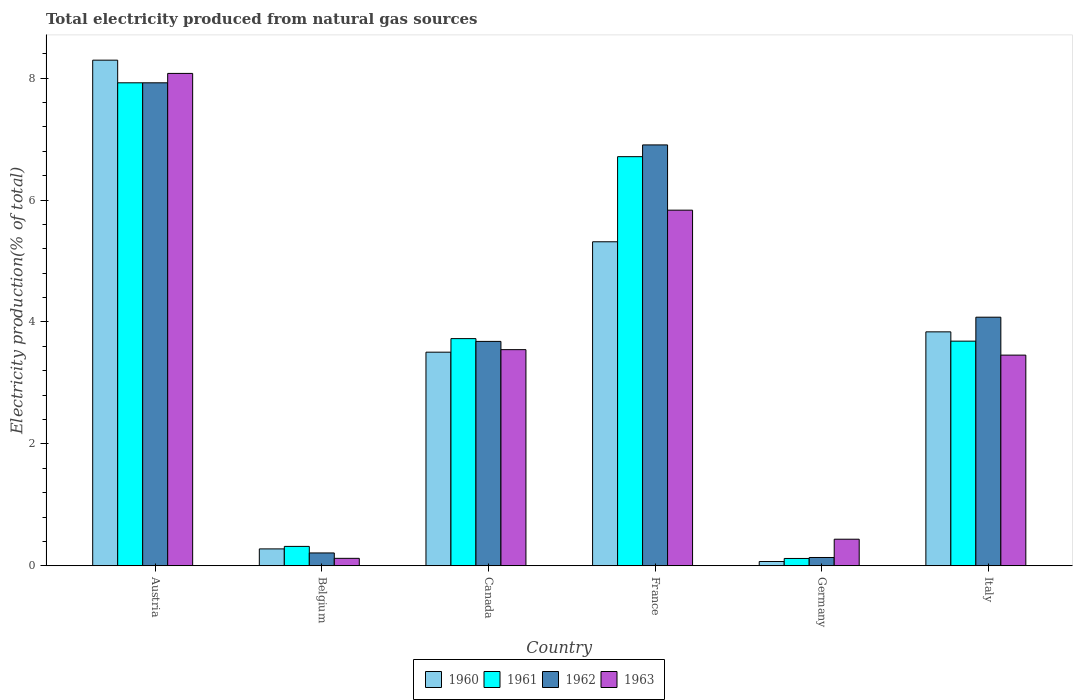How many different coloured bars are there?
Offer a very short reply. 4. Are the number of bars per tick equal to the number of legend labels?
Offer a very short reply. Yes. Are the number of bars on each tick of the X-axis equal?
Give a very brief answer. Yes. How many bars are there on the 6th tick from the right?
Keep it short and to the point. 4. What is the label of the 6th group of bars from the left?
Provide a short and direct response. Italy. In how many cases, is the number of bars for a given country not equal to the number of legend labels?
Offer a terse response. 0. What is the total electricity produced in 1962 in Italy?
Keep it short and to the point. 4.08. Across all countries, what is the maximum total electricity produced in 1961?
Your answer should be very brief. 7.92. Across all countries, what is the minimum total electricity produced in 1962?
Offer a terse response. 0.14. In which country was the total electricity produced in 1962 minimum?
Make the answer very short. Germany. What is the total total electricity produced in 1961 in the graph?
Offer a terse response. 22.49. What is the difference between the total electricity produced in 1961 in Germany and that in Italy?
Offer a very short reply. -3.57. What is the difference between the total electricity produced in 1962 in France and the total electricity produced in 1960 in Austria?
Make the answer very short. -1.39. What is the average total electricity produced in 1963 per country?
Make the answer very short. 3.58. What is the difference between the total electricity produced of/in 1961 and total electricity produced of/in 1962 in France?
Give a very brief answer. -0.19. In how many countries, is the total electricity produced in 1963 greater than 4.8 %?
Your answer should be compact. 2. What is the ratio of the total electricity produced in 1961 in Germany to that in Italy?
Offer a terse response. 0.03. Is the total electricity produced in 1960 in Belgium less than that in Italy?
Your answer should be very brief. Yes. Is the difference between the total electricity produced in 1961 in France and Italy greater than the difference between the total electricity produced in 1962 in France and Italy?
Make the answer very short. Yes. What is the difference between the highest and the second highest total electricity produced in 1960?
Your answer should be compact. 4.46. What is the difference between the highest and the lowest total electricity produced in 1960?
Your answer should be very brief. 8.23. In how many countries, is the total electricity produced in 1960 greater than the average total electricity produced in 1960 taken over all countries?
Make the answer very short. 3. What does the 3rd bar from the left in Austria represents?
Your answer should be compact. 1962. How many countries are there in the graph?
Your answer should be compact. 6. Does the graph contain any zero values?
Provide a succinct answer. No. What is the title of the graph?
Make the answer very short. Total electricity produced from natural gas sources. What is the Electricity production(% of total) of 1960 in Austria?
Make the answer very short. 8.3. What is the Electricity production(% of total) of 1961 in Austria?
Offer a terse response. 7.92. What is the Electricity production(% of total) in 1962 in Austria?
Make the answer very short. 7.92. What is the Electricity production(% of total) in 1963 in Austria?
Provide a succinct answer. 8.08. What is the Electricity production(% of total) of 1960 in Belgium?
Provide a succinct answer. 0.28. What is the Electricity production(% of total) in 1961 in Belgium?
Make the answer very short. 0.32. What is the Electricity production(% of total) in 1962 in Belgium?
Your response must be concise. 0.21. What is the Electricity production(% of total) of 1963 in Belgium?
Ensure brevity in your answer.  0.12. What is the Electricity production(% of total) in 1960 in Canada?
Your answer should be very brief. 3.5. What is the Electricity production(% of total) of 1961 in Canada?
Provide a succinct answer. 3.73. What is the Electricity production(% of total) of 1962 in Canada?
Offer a very short reply. 3.68. What is the Electricity production(% of total) of 1963 in Canada?
Ensure brevity in your answer.  3.55. What is the Electricity production(% of total) in 1960 in France?
Give a very brief answer. 5.32. What is the Electricity production(% of total) in 1961 in France?
Keep it short and to the point. 6.71. What is the Electricity production(% of total) of 1962 in France?
Your answer should be very brief. 6.91. What is the Electricity production(% of total) in 1963 in France?
Give a very brief answer. 5.83. What is the Electricity production(% of total) in 1960 in Germany?
Your answer should be very brief. 0.07. What is the Electricity production(% of total) of 1961 in Germany?
Provide a short and direct response. 0.12. What is the Electricity production(% of total) of 1962 in Germany?
Offer a terse response. 0.14. What is the Electricity production(% of total) of 1963 in Germany?
Your answer should be very brief. 0.44. What is the Electricity production(% of total) of 1960 in Italy?
Provide a short and direct response. 3.84. What is the Electricity production(% of total) in 1961 in Italy?
Make the answer very short. 3.69. What is the Electricity production(% of total) in 1962 in Italy?
Your response must be concise. 4.08. What is the Electricity production(% of total) of 1963 in Italy?
Provide a short and direct response. 3.46. Across all countries, what is the maximum Electricity production(% of total) of 1960?
Offer a very short reply. 8.3. Across all countries, what is the maximum Electricity production(% of total) of 1961?
Make the answer very short. 7.92. Across all countries, what is the maximum Electricity production(% of total) of 1962?
Keep it short and to the point. 7.92. Across all countries, what is the maximum Electricity production(% of total) of 1963?
Offer a very short reply. 8.08. Across all countries, what is the minimum Electricity production(% of total) in 1960?
Offer a terse response. 0.07. Across all countries, what is the minimum Electricity production(% of total) of 1961?
Give a very brief answer. 0.12. Across all countries, what is the minimum Electricity production(% of total) of 1962?
Your response must be concise. 0.14. Across all countries, what is the minimum Electricity production(% of total) of 1963?
Your response must be concise. 0.12. What is the total Electricity production(% of total) of 1960 in the graph?
Make the answer very short. 21.3. What is the total Electricity production(% of total) in 1961 in the graph?
Provide a succinct answer. 22.49. What is the total Electricity production(% of total) of 1962 in the graph?
Offer a very short reply. 22.94. What is the total Electricity production(% of total) in 1963 in the graph?
Give a very brief answer. 21.47. What is the difference between the Electricity production(% of total) in 1960 in Austria and that in Belgium?
Your response must be concise. 8.02. What is the difference between the Electricity production(% of total) of 1961 in Austria and that in Belgium?
Your answer should be compact. 7.61. What is the difference between the Electricity production(% of total) of 1962 in Austria and that in Belgium?
Provide a short and direct response. 7.71. What is the difference between the Electricity production(% of total) in 1963 in Austria and that in Belgium?
Give a very brief answer. 7.96. What is the difference between the Electricity production(% of total) in 1960 in Austria and that in Canada?
Your answer should be very brief. 4.79. What is the difference between the Electricity production(% of total) in 1961 in Austria and that in Canada?
Offer a very short reply. 4.2. What is the difference between the Electricity production(% of total) of 1962 in Austria and that in Canada?
Your answer should be compact. 4.24. What is the difference between the Electricity production(% of total) in 1963 in Austria and that in Canada?
Give a very brief answer. 4.53. What is the difference between the Electricity production(% of total) in 1960 in Austria and that in France?
Ensure brevity in your answer.  2.98. What is the difference between the Electricity production(% of total) in 1961 in Austria and that in France?
Offer a very short reply. 1.21. What is the difference between the Electricity production(% of total) in 1962 in Austria and that in France?
Make the answer very short. 1.02. What is the difference between the Electricity production(% of total) of 1963 in Austria and that in France?
Make the answer very short. 2.24. What is the difference between the Electricity production(% of total) of 1960 in Austria and that in Germany?
Offer a very short reply. 8.23. What is the difference between the Electricity production(% of total) in 1961 in Austria and that in Germany?
Give a very brief answer. 7.8. What is the difference between the Electricity production(% of total) of 1962 in Austria and that in Germany?
Ensure brevity in your answer.  7.79. What is the difference between the Electricity production(% of total) in 1963 in Austria and that in Germany?
Offer a very short reply. 7.64. What is the difference between the Electricity production(% of total) of 1960 in Austria and that in Italy?
Offer a very short reply. 4.46. What is the difference between the Electricity production(% of total) of 1961 in Austria and that in Italy?
Give a very brief answer. 4.24. What is the difference between the Electricity production(% of total) in 1962 in Austria and that in Italy?
Provide a succinct answer. 3.85. What is the difference between the Electricity production(% of total) in 1963 in Austria and that in Italy?
Provide a succinct answer. 4.62. What is the difference between the Electricity production(% of total) of 1960 in Belgium and that in Canada?
Ensure brevity in your answer.  -3.23. What is the difference between the Electricity production(% of total) in 1961 in Belgium and that in Canada?
Your response must be concise. -3.41. What is the difference between the Electricity production(% of total) in 1962 in Belgium and that in Canada?
Your answer should be very brief. -3.47. What is the difference between the Electricity production(% of total) in 1963 in Belgium and that in Canada?
Offer a very short reply. -3.42. What is the difference between the Electricity production(% of total) of 1960 in Belgium and that in France?
Ensure brevity in your answer.  -5.04. What is the difference between the Electricity production(% of total) in 1961 in Belgium and that in France?
Your answer should be very brief. -6.39. What is the difference between the Electricity production(% of total) of 1962 in Belgium and that in France?
Offer a terse response. -6.69. What is the difference between the Electricity production(% of total) of 1963 in Belgium and that in France?
Offer a terse response. -5.71. What is the difference between the Electricity production(% of total) of 1960 in Belgium and that in Germany?
Provide a succinct answer. 0.21. What is the difference between the Electricity production(% of total) in 1961 in Belgium and that in Germany?
Your response must be concise. 0.2. What is the difference between the Electricity production(% of total) of 1962 in Belgium and that in Germany?
Your answer should be compact. 0.07. What is the difference between the Electricity production(% of total) of 1963 in Belgium and that in Germany?
Offer a terse response. -0.31. What is the difference between the Electricity production(% of total) in 1960 in Belgium and that in Italy?
Provide a short and direct response. -3.56. What is the difference between the Electricity production(% of total) in 1961 in Belgium and that in Italy?
Ensure brevity in your answer.  -3.37. What is the difference between the Electricity production(% of total) in 1962 in Belgium and that in Italy?
Offer a terse response. -3.87. What is the difference between the Electricity production(% of total) of 1963 in Belgium and that in Italy?
Offer a very short reply. -3.33. What is the difference between the Electricity production(% of total) in 1960 in Canada and that in France?
Your response must be concise. -1.81. What is the difference between the Electricity production(% of total) in 1961 in Canada and that in France?
Offer a very short reply. -2.99. What is the difference between the Electricity production(% of total) in 1962 in Canada and that in France?
Your answer should be very brief. -3.22. What is the difference between the Electricity production(% of total) of 1963 in Canada and that in France?
Offer a very short reply. -2.29. What is the difference between the Electricity production(% of total) in 1960 in Canada and that in Germany?
Ensure brevity in your answer.  3.43. What is the difference between the Electricity production(% of total) of 1961 in Canada and that in Germany?
Your response must be concise. 3.61. What is the difference between the Electricity production(% of total) in 1962 in Canada and that in Germany?
Make the answer very short. 3.55. What is the difference between the Electricity production(% of total) of 1963 in Canada and that in Germany?
Give a very brief answer. 3.11. What is the difference between the Electricity production(% of total) of 1960 in Canada and that in Italy?
Ensure brevity in your answer.  -0.33. What is the difference between the Electricity production(% of total) in 1961 in Canada and that in Italy?
Provide a succinct answer. 0.04. What is the difference between the Electricity production(% of total) of 1962 in Canada and that in Italy?
Provide a short and direct response. -0.4. What is the difference between the Electricity production(% of total) in 1963 in Canada and that in Italy?
Your response must be concise. 0.09. What is the difference between the Electricity production(% of total) of 1960 in France and that in Germany?
Provide a succinct answer. 5.25. What is the difference between the Electricity production(% of total) in 1961 in France and that in Germany?
Your response must be concise. 6.59. What is the difference between the Electricity production(% of total) in 1962 in France and that in Germany?
Give a very brief answer. 6.77. What is the difference between the Electricity production(% of total) of 1963 in France and that in Germany?
Provide a succinct answer. 5.4. What is the difference between the Electricity production(% of total) in 1960 in France and that in Italy?
Give a very brief answer. 1.48. What is the difference between the Electricity production(% of total) of 1961 in France and that in Italy?
Keep it short and to the point. 3.03. What is the difference between the Electricity production(% of total) in 1962 in France and that in Italy?
Offer a very short reply. 2.83. What is the difference between the Electricity production(% of total) in 1963 in France and that in Italy?
Your answer should be very brief. 2.38. What is the difference between the Electricity production(% of total) of 1960 in Germany and that in Italy?
Your answer should be very brief. -3.77. What is the difference between the Electricity production(% of total) of 1961 in Germany and that in Italy?
Provide a short and direct response. -3.57. What is the difference between the Electricity production(% of total) in 1962 in Germany and that in Italy?
Your answer should be compact. -3.94. What is the difference between the Electricity production(% of total) of 1963 in Germany and that in Italy?
Your answer should be very brief. -3.02. What is the difference between the Electricity production(% of total) of 1960 in Austria and the Electricity production(% of total) of 1961 in Belgium?
Offer a terse response. 7.98. What is the difference between the Electricity production(% of total) of 1960 in Austria and the Electricity production(% of total) of 1962 in Belgium?
Your answer should be compact. 8.08. What is the difference between the Electricity production(% of total) of 1960 in Austria and the Electricity production(% of total) of 1963 in Belgium?
Make the answer very short. 8.17. What is the difference between the Electricity production(% of total) of 1961 in Austria and the Electricity production(% of total) of 1962 in Belgium?
Your answer should be very brief. 7.71. What is the difference between the Electricity production(% of total) of 1961 in Austria and the Electricity production(% of total) of 1963 in Belgium?
Offer a very short reply. 7.8. What is the difference between the Electricity production(% of total) in 1962 in Austria and the Electricity production(% of total) in 1963 in Belgium?
Offer a very short reply. 7.8. What is the difference between the Electricity production(% of total) in 1960 in Austria and the Electricity production(% of total) in 1961 in Canada?
Provide a succinct answer. 4.57. What is the difference between the Electricity production(% of total) in 1960 in Austria and the Electricity production(% of total) in 1962 in Canada?
Provide a succinct answer. 4.61. What is the difference between the Electricity production(% of total) of 1960 in Austria and the Electricity production(% of total) of 1963 in Canada?
Give a very brief answer. 4.75. What is the difference between the Electricity production(% of total) of 1961 in Austria and the Electricity production(% of total) of 1962 in Canada?
Ensure brevity in your answer.  4.24. What is the difference between the Electricity production(% of total) in 1961 in Austria and the Electricity production(% of total) in 1963 in Canada?
Offer a terse response. 4.38. What is the difference between the Electricity production(% of total) in 1962 in Austria and the Electricity production(% of total) in 1963 in Canada?
Your answer should be compact. 4.38. What is the difference between the Electricity production(% of total) of 1960 in Austria and the Electricity production(% of total) of 1961 in France?
Give a very brief answer. 1.58. What is the difference between the Electricity production(% of total) of 1960 in Austria and the Electricity production(% of total) of 1962 in France?
Provide a succinct answer. 1.39. What is the difference between the Electricity production(% of total) of 1960 in Austria and the Electricity production(% of total) of 1963 in France?
Make the answer very short. 2.46. What is the difference between the Electricity production(% of total) in 1961 in Austria and the Electricity production(% of total) in 1962 in France?
Provide a succinct answer. 1.02. What is the difference between the Electricity production(% of total) of 1961 in Austria and the Electricity production(% of total) of 1963 in France?
Provide a short and direct response. 2.09. What is the difference between the Electricity production(% of total) of 1962 in Austria and the Electricity production(% of total) of 1963 in France?
Make the answer very short. 2.09. What is the difference between the Electricity production(% of total) in 1960 in Austria and the Electricity production(% of total) in 1961 in Germany?
Provide a short and direct response. 8.18. What is the difference between the Electricity production(% of total) of 1960 in Austria and the Electricity production(% of total) of 1962 in Germany?
Offer a terse response. 8.16. What is the difference between the Electricity production(% of total) in 1960 in Austria and the Electricity production(% of total) in 1963 in Germany?
Provide a succinct answer. 7.86. What is the difference between the Electricity production(% of total) of 1961 in Austria and the Electricity production(% of total) of 1962 in Germany?
Offer a very short reply. 7.79. What is the difference between the Electricity production(% of total) of 1961 in Austria and the Electricity production(% of total) of 1963 in Germany?
Ensure brevity in your answer.  7.49. What is the difference between the Electricity production(% of total) in 1962 in Austria and the Electricity production(% of total) in 1963 in Germany?
Keep it short and to the point. 7.49. What is the difference between the Electricity production(% of total) in 1960 in Austria and the Electricity production(% of total) in 1961 in Italy?
Offer a very short reply. 4.61. What is the difference between the Electricity production(% of total) in 1960 in Austria and the Electricity production(% of total) in 1962 in Italy?
Keep it short and to the point. 4.22. What is the difference between the Electricity production(% of total) in 1960 in Austria and the Electricity production(% of total) in 1963 in Italy?
Ensure brevity in your answer.  4.84. What is the difference between the Electricity production(% of total) of 1961 in Austria and the Electricity production(% of total) of 1962 in Italy?
Provide a succinct answer. 3.85. What is the difference between the Electricity production(% of total) in 1961 in Austria and the Electricity production(% of total) in 1963 in Italy?
Your answer should be very brief. 4.47. What is the difference between the Electricity production(% of total) in 1962 in Austria and the Electricity production(% of total) in 1963 in Italy?
Give a very brief answer. 4.47. What is the difference between the Electricity production(% of total) in 1960 in Belgium and the Electricity production(% of total) in 1961 in Canada?
Offer a very short reply. -3.45. What is the difference between the Electricity production(% of total) of 1960 in Belgium and the Electricity production(% of total) of 1962 in Canada?
Keep it short and to the point. -3.4. What is the difference between the Electricity production(% of total) in 1960 in Belgium and the Electricity production(% of total) in 1963 in Canada?
Provide a short and direct response. -3.27. What is the difference between the Electricity production(% of total) of 1961 in Belgium and the Electricity production(% of total) of 1962 in Canada?
Your answer should be very brief. -3.36. What is the difference between the Electricity production(% of total) in 1961 in Belgium and the Electricity production(% of total) in 1963 in Canada?
Make the answer very short. -3.23. What is the difference between the Electricity production(% of total) in 1962 in Belgium and the Electricity production(% of total) in 1963 in Canada?
Offer a terse response. -3.34. What is the difference between the Electricity production(% of total) of 1960 in Belgium and the Electricity production(% of total) of 1961 in France?
Provide a short and direct response. -6.43. What is the difference between the Electricity production(% of total) in 1960 in Belgium and the Electricity production(% of total) in 1962 in France?
Provide a short and direct response. -6.63. What is the difference between the Electricity production(% of total) in 1960 in Belgium and the Electricity production(% of total) in 1963 in France?
Ensure brevity in your answer.  -5.56. What is the difference between the Electricity production(% of total) in 1961 in Belgium and the Electricity production(% of total) in 1962 in France?
Your answer should be compact. -6.59. What is the difference between the Electricity production(% of total) in 1961 in Belgium and the Electricity production(% of total) in 1963 in France?
Your answer should be very brief. -5.52. What is the difference between the Electricity production(% of total) of 1962 in Belgium and the Electricity production(% of total) of 1963 in France?
Your answer should be compact. -5.62. What is the difference between the Electricity production(% of total) in 1960 in Belgium and the Electricity production(% of total) in 1961 in Germany?
Your answer should be compact. 0.16. What is the difference between the Electricity production(% of total) in 1960 in Belgium and the Electricity production(% of total) in 1962 in Germany?
Keep it short and to the point. 0.14. What is the difference between the Electricity production(% of total) of 1960 in Belgium and the Electricity production(% of total) of 1963 in Germany?
Provide a short and direct response. -0.16. What is the difference between the Electricity production(% of total) in 1961 in Belgium and the Electricity production(% of total) in 1962 in Germany?
Make the answer very short. 0.18. What is the difference between the Electricity production(% of total) in 1961 in Belgium and the Electricity production(% of total) in 1963 in Germany?
Your answer should be compact. -0.12. What is the difference between the Electricity production(% of total) in 1962 in Belgium and the Electricity production(% of total) in 1963 in Germany?
Keep it short and to the point. -0.23. What is the difference between the Electricity production(% of total) of 1960 in Belgium and the Electricity production(% of total) of 1961 in Italy?
Offer a terse response. -3.41. What is the difference between the Electricity production(% of total) of 1960 in Belgium and the Electricity production(% of total) of 1962 in Italy?
Make the answer very short. -3.8. What is the difference between the Electricity production(% of total) in 1960 in Belgium and the Electricity production(% of total) in 1963 in Italy?
Ensure brevity in your answer.  -3.18. What is the difference between the Electricity production(% of total) of 1961 in Belgium and the Electricity production(% of total) of 1962 in Italy?
Keep it short and to the point. -3.76. What is the difference between the Electricity production(% of total) of 1961 in Belgium and the Electricity production(% of total) of 1963 in Italy?
Ensure brevity in your answer.  -3.14. What is the difference between the Electricity production(% of total) in 1962 in Belgium and the Electricity production(% of total) in 1963 in Italy?
Give a very brief answer. -3.25. What is the difference between the Electricity production(% of total) of 1960 in Canada and the Electricity production(% of total) of 1961 in France?
Offer a terse response. -3.21. What is the difference between the Electricity production(% of total) in 1960 in Canada and the Electricity production(% of total) in 1962 in France?
Make the answer very short. -3.4. What is the difference between the Electricity production(% of total) in 1960 in Canada and the Electricity production(% of total) in 1963 in France?
Your answer should be compact. -2.33. What is the difference between the Electricity production(% of total) in 1961 in Canada and the Electricity production(% of total) in 1962 in France?
Give a very brief answer. -3.18. What is the difference between the Electricity production(% of total) in 1961 in Canada and the Electricity production(% of total) in 1963 in France?
Offer a very short reply. -2.11. What is the difference between the Electricity production(% of total) of 1962 in Canada and the Electricity production(% of total) of 1963 in France?
Make the answer very short. -2.15. What is the difference between the Electricity production(% of total) of 1960 in Canada and the Electricity production(% of total) of 1961 in Germany?
Make the answer very short. 3.38. What is the difference between the Electricity production(% of total) of 1960 in Canada and the Electricity production(% of total) of 1962 in Germany?
Ensure brevity in your answer.  3.37. What is the difference between the Electricity production(% of total) of 1960 in Canada and the Electricity production(% of total) of 1963 in Germany?
Ensure brevity in your answer.  3.07. What is the difference between the Electricity production(% of total) in 1961 in Canada and the Electricity production(% of total) in 1962 in Germany?
Provide a succinct answer. 3.59. What is the difference between the Electricity production(% of total) of 1961 in Canada and the Electricity production(% of total) of 1963 in Germany?
Offer a very short reply. 3.29. What is the difference between the Electricity production(% of total) of 1962 in Canada and the Electricity production(% of total) of 1963 in Germany?
Your answer should be compact. 3.25. What is the difference between the Electricity production(% of total) of 1960 in Canada and the Electricity production(% of total) of 1961 in Italy?
Ensure brevity in your answer.  -0.18. What is the difference between the Electricity production(% of total) in 1960 in Canada and the Electricity production(% of total) in 1962 in Italy?
Give a very brief answer. -0.57. What is the difference between the Electricity production(% of total) in 1960 in Canada and the Electricity production(% of total) in 1963 in Italy?
Give a very brief answer. 0.05. What is the difference between the Electricity production(% of total) in 1961 in Canada and the Electricity production(% of total) in 1962 in Italy?
Keep it short and to the point. -0.35. What is the difference between the Electricity production(% of total) of 1961 in Canada and the Electricity production(% of total) of 1963 in Italy?
Your response must be concise. 0.27. What is the difference between the Electricity production(% of total) in 1962 in Canada and the Electricity production(% of total) in 1963 in Italy?
Offer a very short reply. 0.23. What is the difference between the Electricity production(% of total) in 1960 in France and the Electricity production(% of total) in 1961 in Germany?
Keep it short and to the point. 5.2. What is the difference between the Electricity production(% of total) in 1960 in France and the Electricity production(% of total) in 1962 in Germany?
Ensure brevity in your answer.  5.18. What is the difference between the Electricity production(% of total) in 1960 in France and the Electricity production(% of total) in 1963 in Germany?
Offer a very short reply. 4.88. What is the difference between the Electricity production(% of total) of 1961 in France and the Electricity production(% of total) of 1962 in Germany?
Your response must be concise. 6.58. What is the difference between the Electricity production(% of total) in 1961 in France and the Electricity production(% of total) in 1963 in Germany?
Offer a terse response. 6.28. What is the difference between the Electricity production(% of total) of 1962 in France and the Electricity production(% of total) of 1963 in Germany?
Ensure brevity in your answer.  6.47. What is the difference between the Electricity production(% of total) of 1960 in France and the Electricity production(% of total) of 1961 in Italy?
Your response must be concise. 1.63. What is the difference between the Electricity production(% of total) of 1960 in France and the Electricity production(% of total) of 1962 in Italy?
Your answer should be compact. 1.24. What is the difference between the Electricity production(% of total) in 1960 in France and the Electricity production(% of total) in 1963 in Italy?
Make the answer very short. 1.86. What is the difference between the Electricity production(% of total) in 1961 in France and the Electricity production(% of total) in 1962 in Italy?
Ensure brevity in your answer.  2.63. What is the difference between the Electricity production(% of total) of 1961 in France and the Electricity production(% of total) of 1963 in Italy?
Your answer should be compact. 3.26. What is the difference between the Electricity production(% of total) of 1962 in France and the Electricity production(% of total) of 1963 in Italy?
Your response must be concise. 3.45. What is the difference between the Electricity production(% of total) of 1960 in Germany and the Electricity production(% of total) of 1961 in Italy?
Your answer should be compact. -3.62. What is the difference between the Electricity production(% of total) in 1960 in Germany and the Electricity production(% of total) in 1962 in Italy?
Offer a terse response. -4.01. What is the difference between the Electricity production(% of total) in 1960 in Germany and the Electricity production(% of total) in 1963 in Italy?
Make the answer very short. -3.39. What is the difference between the Electricity production(% of total) in 1961 in Germany and the Electricity production(% of total) in 1962 in Italy?
Your response must be concise. -3.96. What is the difference between the Electricity production(% of total) in 1961 in Germany and the Electricity production(% of total) in 1963 in Italy?
Give a very brief answer. -3.34. What is the difference between the Electricity production(% of total) in 1962 in Germany and the Electricity production(% of total) in 1963 in Italy?
Keep it short and to the point. -3.32. What is the average Electricity production(% of total) of 1960 per country?
Ensure brevity in your answer.  3.55. What is the average Electricity production(% of total) in 1961 per country?
Ensure brevity in your answer.  3.75. What is the average Electricity production(% of total) in 1962 per country?
Give a very brief answer. 3.82. What is the average Electricity production(% of total) of 1963 per country?
Give a very brief answer. 3.58. What is the difference between the Electricity production(% of total) in 1960 and Electricity production(% of total) in 1961 in Austria?
Make the answer very short. 0.37. What is the difference between the Electricity production(% of total) in 1960 and Electricity production(% of total) in 1962 in Austria?
Offer a very short reply. 0.37. What is the difference between the Electricity production(% of total) in 1960 and Electricity production(% of total) in 1963 in Austria?
Your response must be concise. 0.22. What is the difference between the Electricity production(% of total) of 1961 and Electricity production(% of total) of 1963 in Austria?
Your answer should be very brief. -0.15. What is the difference between the Electricity production(% of total) in 1962 and Electricity production(% of total) in 1963 in Austria?
Your answer should be compact. -0.15. What is the difference between the Electricity production(% of total) of 1960 and Electricity production(% of total) of 1961 in Belgium?
Ensure brevity in your answer.  -0.04. What is the difference between the Electricity production(% of total) of 1960 and Electricity production(% of total) of 1962 in Belgium?
Offer a terse response. 0.07. What is the difference between the Electricity production(% of total) of 1960 and Electricity production(% of total) of 1963 in Belgium?
Make the answer very short. 0.15. What is the difference between the Electricity production(% of total) of 1961 and Electricity production(% of total) of 1962 in Belgium?
Your answer should be very brief. 0.11. What is the difference between the Electricity production(% of total) in 1961 and Electricity production(% of total) in 1963 in Belgium?
Your answer should be very brief. 0.2. What is the difference between the Electricity production(% of total) in 1962 and Electricity production(% of total) in 1963 in Belgium?
Keep it short and to the point. 0.09. What is the difference between the Electricity production(% of total) of 1960 and Electricity production(% of total) of 1961 in Canada?
Give a very brief answer. -0.22. What is the difference between the Electricity production(% of total) in 1960 and Electricity production(% of total) in 1962 in Canada?
Provide a succinct answer. -0.18. What is the difference between the Electricity production(% of total) of 1960 and Electricity production(% of total) of 1963 in Canada?
Make the answer very short. -0.04. What is the difference between the Electricity production(% of total) of 1961 and Electricity production(% of total) of 1962 in Canada?
Make the answer very short. 0.05. What is the difference between the Electricity production(% of total) in 1961 and Electricity production(% of total) in 1963 in Canada?
Ensure brevity in your answer.  0.18. What is the difference between the Electricity production(% of total) in 1962 and Electricity production(% of total) in 1963 in Canada?
Make the answer very short. 0.14. What is the difference between the Electricity production(% of total) in 1960 and Electricity production(% of total) in 1961 in France?
Offer a terse response. -1.4. What is the difference between the Electricity production(% of total) in 1960 and Electricity production(% of total) in 1962 in France?
Ensure brevity in your answer.  -1.59. What is the difference between the Electricity production(% of total) of 1960 and Electricity production(% of total) of 1963 in France?
Give a very brief answer. -0.52. What is the difference between the Electricity production(% of total) of 1961 and Electricity production(% of total) of 1962 in France?
Ensure brevity in your answer.  -0.19. What is the difference between the Electricity production(% of total) of 1961 and Electricity production(% of total) of 1963 in France?
Offer a very short reply. 0.88. What is the difference between the Electricity production(% of total) in 1962 and Electricity production(% of total) in 1963 in France?
Your answer should be very brief. 1.07. What is the difference between the Electricity production(% of total) of 1960 and Electricity production(% of total) of 1961 in Germany?
Provide a succinct answer. -0.05. What is the difference between the Electricity production(% of total) of 1960 and Electricity production(% of total) of 1962 in Germany?
Keep it short and to the point. -0.07. What is the difference between the Electricity production(% of total) of 1960 and Electricity production(% of total) of 1963 in Germany?
Your response must be concise. -0.37. What is the difference between the Electricity production(% of total) in 1961 and Electricity production(% of total) in 1962 in Germany?
Offer a very short reply. -0.02. What is the difference between the Electricity production(% of total) in 1961 and Electricity production(% of total) in 1963 in Germany?
Make the answer very short. -0.32. What is the difference between the Electricity production(% of total) of 1962 and Electricity production(% of total) of 1963 in Germany?
Ensure brevity in your answer.  -0.3. What is the difference between the Electricity production(% of total) of 1960 and Electricity production(% of total) of 1961 in Italy?
Make the answer very short. 0.15. What is the difference between the Electricity production(% of total) in 1960 and Electricity production(% of total) in 1962 in Italy?
Make the answer very short. -0.24. What is the difference between the Electricity production(% of total) in 1960 and Electricity production(% of total) in 1963 in Italy?
Your answer should be very brief. 0.38. What is the difference between the Electricity production(% of total) in 1961 and Electricity production(% of total) in 1962 in Italy?
Give a very brief answer. -0.39. What is the difference between the Electricity production(% of total) of 1961 and Electricity production(% of total) of 1963 in Italy?
Provide a succinct answer. 0.23. What is the difference between the Electricity production(% of total) in 1962 and Electricity production(% of total) in 1963 in Italy?
Offer a terse response. 0.62. What is the ratio of the Electricity production(% of total) of 1960 in Austria to that in Belgium?
Your response must be concise. 29.93. What is the ratio of the Electricity production(% of total) in 1961 in Austria to that in Belgium?
Ensure brevity in your answer.  24.9. What is the ratio of the Electricity production(% of total) in 1962 in Austria to that in Belgium?
Give a very brief answer. 37.57. What is the ratio of the Electricity production(% of total) in 1963 in Austria to that in Belgium?
Make the answer very short. 66.07. What is the ratio of the Electricity production(% of total) in 1960 in Austria to that in Canada?
Offer a very short reply. 2.37. What is the ratio of the Electricity production(% of total) in 1961 in Austria to that in Canada?
Your answer should be compact. 2.13. What is the ratio of the Electricity production(% of total) in 1962 in Austria to that in Canada?
Your answer should be compact. 2.15. What is the ratio of the Electricity production(% of total) in 1963 in Austria to that in Canada?
Ensure brevity in your answer.  2.28. What is the ratio of the Electricity production(% of total) in 1960 in Austria to that in France?
Ensure brevity in your answer.  1.56. What is the ratio of the Electricity production(% of total) in 1961 in Austria to that in France?
Your answer should be very brief. 1.18. What is the ratio of the Electricity production(% of total) of 1962 in Austria to that in France?
Your response must be concise. 1.15. What is the ratio of the Electricity production(% of total) of 1963 in Austria to that in France?
Offer a terse response. 1.38. What is the ratio of the Electricity production(% of total) of 1960 in Austria to that in Germany?
Offer a very short reply. 118.01. What is the ratio of the Electricity production(% of total) of 1961 in Austria to that in Germany?
Provide a succinct answer. 65.86. What is the ratio of the Electricity production(% of total) in 1962 in Austria to that in Germany?
Offer a very short reply. 58.17. What is the ratio of the Electricity production(% of total) of 1963 in Austria to that in Germany?
Your answer should be very brief. 18.52. What is the ratio of the Electricity production(% of total) in 1960 in Austria to that in Italy?
Offer a terse response. 2.16. What is the ratio of the Electricity production(% of total) of 1961 in Austria to that in Italy?
Ensure brevity in your answer.  2.15. What is the ratio of the Electricity production(% of total) of 1962 in Austria to that in Italy?
Provide a short and direct response. 1.94. What is the ratio of the Electricity production(% of total) of 1963 in Austria to that in Italy?
Offer a terse response. 2.34. What is the ratio of the Electricity production(% of total) in 1960 in Belgium to that in Canada?
Ensure brevity in your answer.  0.08. What is the ratio of the Electricity production(% of total) in 1961 in Belgium to that in Canada?
Make the answer very short. 0.09. What is the ratio of the Electricity production(% of total) of 1962 in Belgium to that in Canada?
Your response must be concise. 0.06. What is the ratio of the Electricity production(% of total) in 1963 in Belgium to that in Canada?
Provide a succinct answer. 0.03. What is the ratio of the Electricity production(% of total) in 1960 in Belgium to that in France?
Your answer should be very brief. 0.05. What is the ratio of the Electricity production(% of total) in 1961 in Belgium to that in France?
Keep it short and to the point. 0.05. What is the ratio of the Electricity production(% of total) in 1962 in Belgium to that in France?
Your response must be concise. 0.03. What is the ratio of the Electricity production(% of total) of 1963 in Belgium to that in France?
Provide a succinct answer. 0.02. What is the ratio of the Electricity production(% of total) of 1960 in Belgium to that in Germany?
Make the answer very short. 3.94. What is the ratio of the Electricity production(% of total) in 1961 in Belgium to that in Germany?
Your answer should be compact. 2.64. What is the ratio of the Electricity production(% of total) in 1962 in Belgium to that in Germany?
Keep it short and to the point. 1.55. What is the ratio of the Electricity production(% of total) in 1963 in Belgium to that in Germany?
Your answer should be compact. 0.28. What is the ratio of the Electricity production(% of total) in 1960 in Belgium to that in Italy?
Keep it short and to the point. 0.07. What is the ratio of the Electricity production(% of total) of 1961 in Belgium to that in Italy?
Provide a short and direct response. 0.09. What is the ratio of the Electricity production(% of total) of 1962 in Belgium to that in Italy?
Your answer should be very brief. 0.05. What is the ratio of the Electricity production(% of total) of 1963 in Belgium to that in Italy?
Your answer should be compact. 0.04. What is the ratio of the Electricity production(% of total) of 1960 in Canada to that in France?
Your response must be concise. 0.66. What is the ratio of the Electricity production(% of total) of 1961 in Canada to that in France?
Your answer should be compact. 0.56. What is the ratio of the Electricity production(% of total) in 1962 in Canada to that in France?
Your answer should be very brief. 0.53. What is the ratio of the Electricity production(% of total) in 1963 in Canada to that in France?
Offer a very short reply. 0.61. What is the ratio of the Electricity production(% of total) in 1960 in Canada to that in Germany?
Provide a succinct answer. 49.85. What is the ratio of the Electricity production(% of total) in 1961 in Canada to that in Germany?
Keep it short and to the point. 30.98. What is the ratio of the Electricity production(% of total) of 1962 in Canada to that in Germany?
Provide a succinct answer. 27.02. What is the ratio of the Electricity production(% of total) in 1963 in Canada to that in Germany?
Give a very brief answer. 8.13. What is the ratio of the Electricity production(% of total) in 1960 in Canada to that in Italy?
Provide a short and direct response. 0.91. What is the ratio of the Electricity production(% of total) in 1961 in Canada to that in Italy?
Make the answer very short. 1.01. What is the ratio of the Electricity production(% of total) in 1962 in Canada to that in Italy?
Your answer should be very brief. 0.9. What is the ratio of the Electricity production(% of total) in 1963 in Canada to that in Italy?
Offer a very short reply. 1.03. What is the ratio of the Electricity production(% of total) in 1960 in France to that in Germany?
Ensure brevity in your answer.  75.62. What is the ratio of the Electricity production(% of total) in 1961 in France to that in Germany?
Give a very brief answer. 55.79. What is the ratio of the Electricity production(% of total) in 1962 in France to that in Germany?
Your response must be concise. 50.69. What is the ratio of the Electricity production(% of total) in 1963 in France to that in Germany?
Offer a very short reply. 13.38. What is the ratio of the Electricity production(% of total) in 1960 in France to that in Italy?
Give a very brief answer. 1.39. What is the ratio of the Electricity production(% of total) in 1961 in France to that in Italy?
Offer a terse response. 1.82. What is the ratio of the Electricity production(% of total) in 1962 in France to that in Italy?
Give a very brief answer. 1.69. What is the ratio of the Electricity production(% of total) in 1963 in France to that in Italy?
Give a very brief answer. 1.69. What is the ratio of the Electricity production(% of total) of 1960 in Germany to that in Italy?
Offer a terse response. 0.02. What is the ratio of the Electricity production(% of total) in 1961 in Germany to that in Italy?
Offer a terse response. 0.03. What is the ratio of the Electricity production(% of total) of 1962 in Germany to that in Italy?
Give a very brief answer. 0.03. What is the ratio of the Electricity production(% of total) in 1963 in Germany to that in Italy?
Give a very brief answer. 0.13. What is the difference between the highest and the second highest Electricity production(% of total) in 1960?
Keep it short and to the point. 2.98. What is the difference between the highest and the second highest Electricity production(% of total) in 1961?
Ensure brevity in your answer.  1.21. What is the difference between the highest and the second highest Electricity production(% of total) in 1963?
Ensure brevity in your answer.  2.24. What is the difference between the highest and the lowest Electricity production(% of total) in 1960?
Offer a terse response. 8.23. What is the difference between the highest and the lowest Electricity production(% of total) in 1961?
Your answer should be very brief. 7.8. What is the difference between the highest and the lowest Electricity production(% of total) in 1962?
Your answer should be compact. 7.79. What is the difference between the highest and the lowest Electricity production(% of total) of 1963?
Make the answer very short. 7.96. 